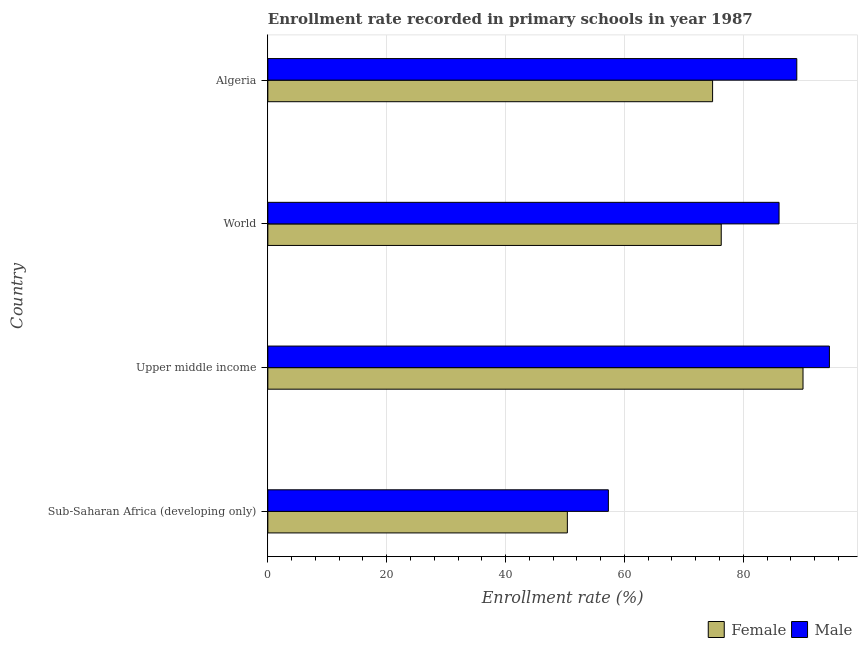How many groups of bars are there?
Keep it short and to the point. 4. Are the number of bars per tick equal to the number of legend labels?
Your response must be concise. Yes. Are the number of bars on each tick of the Y-axis equal?
Provide a succinct answer. Yes. How many bars are there on the 3rd tick from the top?
Give a very brief answer. 2. How many bars are there on the 4th tick from the bottom?
Your answer should be compact. 2. What is the label of the 3rd group of bars from the top?
Provide a short and direct response. Upper middle income. What is the enrollment rate of male students in World?
Your response must be concise. 86.02. Across all countries, what is the maximum enrollment rate of female students?
Offer a terse response. 90.05. Across all countries, what is the minimum enrollment rate of male students?
Give a very brief answer. 57.3. In which country was the enrollment rate of male students maximum?
Provide a succinct answer. Upper middle income. In which country was the enrollment rate of female students minimum?
Your answer should be compact. Sub-Saharan Africa (developing only). What is the total enrollment rate of male students in the graph?
Provide a short and direct response. 326.83. What is the difference between the enrollment rate of female students in Algeria and that in World?
Provide a succinct answer. -1.46. What is the difference between the enrollment rate of female students in World and the enrollment rate of male students in Upper middle income?
Give a very brief answer. -18.2. What is the average enrollment rate of male students per country?
Give a very brief answer. 81.71. What is the difference between the enrollment rate of male students and enrollment rate of female students in Sub-Saharan Africa (developing only)?
Provide a short and direct response. 6.9. In how many countries, is the enrollment rate of female students greater than 20 %?
Offer a terse response. 4. Is the difference between the enrollment rate of male students in Algeria and Upper middle income greater than the difference between the enrollment rate of female students in Algeria and Upper middle income?
Offer a very short reply. Yes. What is the difference between the highest and the second highest enrollment rate of female students?
Keep it short and to the point. 13.76. What is the difference between the highest and the lowest enrollment rate of male students?
Your response must be concise. 37.19. In how many countries, is the enrollment rate of male students greater than the average enrollment rate of male students taken over all countries?
Give a very brief answer. 3. What does the 2nd bar from the top in Upper middle income represents?
Keep it short and to the point. Female. What does the 2nd bar from the bottom in World represents?
Offer a very short reply. Male. How many bars are there?
Provide a succinct answer. 8. How many countries are there in the graph?
Offer a terse response. 4. What is the difference between two consecutive major ticks on the X-axis?
Your response must be concise. 20. Are the values on the major ticks of X-axis written in scientific E-notation?
Keep it short and to the point. No. Does the graph contain any zero values?
Offer a very short reply. No. How are the legend labels stacked?
Make the answer very short. Horizontal. What is the title of the graph?
Ensure brevity in your answer.  Enrollment rate recorded in primary schools in year 1987. What is the label or title of the X-axis?
Keep it short and to the point. Enrollment rate (%). What is the label or title of the Y-axis?
Provide a succinct answer. Country. What is the Enrollment rate (%) of Female in Sub-Saharan Africa (developing only)?
Offer a terse response. 50.4. What is the Enrollment rate (%) of Male in Sub-Saharan Africa (developing only)?
Make the answer very short. 57.3. What is the Enrollment rate (%) of Female in Upper middle income?
Your answer should be compact. 90.05. What is the Enrollment rate (%) in Male in Upper middle income?
Your answer should be very brief. 94.5. What is the Enrollment rate (%) in Female in World?
Ensure brevity in your answer.  76.29. What is the Enrollment rate (%) in Male in World?
Offer a terse response. 86.02. What is the Enrollment rate (%) of Female in Algeria?
Provide a short and direct response. 74.84. What is the Enrollment rate (%) in Male in Algeria?
Offer a terse response. 89.01. Across all countries, what is the maximum Enrollment rate (%) of Female?
Your response must be concise. 90.05. Across all countries, what is the maximum Enrollment rate (%) in Male?
Provide a succinct answer. 94.5. Across all countries, what is the minimum Enrollment rate (%) in Female?
Keep it short and to the point. 50.4. Across all countries, what is the minimum Enrollment rate (%) of Male?
Provide a succinct answer. 57.3. What is the total Enrollment rate (%) in Female in the graph?
Keep it short and to the point. 291.58. What is the total Enrollment rate (%) in Male in the graph?
Give a very brief answer. 326.83. What is the difference between the Enrollment rate (%) in Female in Sub-Saharan Africa (developing only) and that in Upper middle income?
Your answer should be compact. -39.65. What is the difference between the Enrollment rate (%) of Male in Sub-Saharan Africa (developing only) and that in Upper middle income?
Offer a terse response. -37.19. What is the difference between the Enrollment rate (%) of Female in Sub-Saharan Africa (developing only) and that in World?
Provide a succinct answer. -25.89. What is the difference between the Enrollment rate (%) in Male in Sub-Saharan Africa (developing only) and that in World?
Ensure brevity in your answer.  -28.72. What is the difference between the Enrollment rate (%) of Female in Sub-Saharan Africa (developing only) and that in Algeria?
Make the answer very short. -24.44. What is the difference between the Enrollment rate (%) in Male in Sub-Saharan Africa (developing only) and that in Algeria?
Offer a very short reply. -31.7. What is the difference between the Enrollment rate (%) in Female in Upper middle income and that in World?
Keep it short and to the point. 13.76. What is the difference between the Enrollment rate (%) of Male in Upper middle income and that in World?
Offer a terse response. 8.47. What is the difference between the Enrollment rate (%) in Female in Upper middle income and that in Algeria?
Your response must be concise. 15.22. What is the difference between the Enrollment rate (%) of Male in Upper middle income and that in Algeria?
Your answer should be very brief. 5.49. What is the difference between the Enrollment rate (%) of Female in World and that in Algeria?
Offer a very short reply. 1.46. What is the difference between the Enrollment rate (%) in Male in World and that in Algeria?
Provide a succinct answer. -2.98. What is the difference between the Enrollment rate (%) of Female in Sub-Saharan Africa (developing only) and the Enrollment rate (%) of Male in Upper middle income?
Keep it short and to the point. -44.1. What is the difference between the Enrollment rate (%) of Female in Sub-Saharan Africa (developing only) and the Enrollment rate (%) of Male in World?
Offer a very short reply. -35.62. What is the difference between the Enrollment rate (%) of Female in Sub-Saharan Africa (developing only) and the Enrollment rate (%) of Male in Algeria?
Make the answer very short. -38.61. What is the difference between the Enrollment rate (%) of Female in Upper middle income and the Enrollment rate (%) of Male in World?
Keep it short and to the point. 4.03. What is the difference between the Enrollment rate (%) in Female in Upper middle income and the Enrollment rate (%) in Male in Algeria?
Offer a terse response. 1.05. What is the difference between the Enrollment rate (%) in Female in World and the Enrollment rate (%) in Male in Algeria?
Provide a succinct answer. -12.71. What is the average Enrollment rate (%) of Female per country?
Your response must be concise. 72.9. What is the average Enrollment rate (%) in Male per country?
Provide a succinct answer. 81.71. What is the difference between the Enrollment rate (%) in Female and Enrollment rate (%) in Male in Sub-Saharan Africa (developing only)?
Your answer should be very brief. -6.9. What is the difference between the Enrollment rate (%) of Female and Enrollment rate (%) of Male in Upper middle income?
Your response must be concise. -4.44. What is the difference between the Enrollment rate (%) of Female and Enrollment rate (%) of Male in World?
Offer a terse response. -9.73. What is the difference between the Enrollment rate (%) in Female and Enrollment rate (%) in Male in Algeria?
Your response must be concise. -14.17. What is the ratio of the Enrollment rate (%) in Female in Sub-Saharan Africa (developing only) to that in Upper middle income?
Your answer should be very brief. 0.56. What is the ratio of the Enrollment rate (%) in Male in Sub-Saharan Africa (developing only) to that in Upper middle income?
Give a very brief answer. 0.61. What is the ratio of the Enrollment rate (%) of Female in Sub-Saharan Africa (developing only) to that in World?
Provide a short and direct response. 0.66. What is the ratio of the Enrollment rate (%) in Male in Sub-Saharan Africa (developing only) to that in World?
Offer a very short reply. 0.67. What is the ratio of the Enrollment rate (%) of Female in Sub-Saharan Africa (developing only) to that in Algeria?
Provide a succinct answer. 0.67. What is the ratio of the Enrollment rate (%) in Male in Sub-Saharan Africa (developing only) to that in Algeria?
Provide a short and direct response. 0.64. What is the ratio of the Enrollment rate (%) of Female in Upper middle income to that in World?
Your response must be concise. 1.18. What is the ratio of the Enrollment rate (%) in Male in Upper middle income to that in World?
Offer a very short reply. 1.1. What is the ratio of the Enrollment rate (%) in Female in Upper middle income to that in Algeria?
Give a very brief answer. 1.2. What is the ratio of the Enrollment rate (%) in Male in Upper middle income to that in Algeria?
Your answer should be very brief. 1.06. What is the ratio of the Enrollment rate (%) of Female in World to that in Algeria?
Ensure brevity in your answer.  1.02. What is the ratio of the Enrollment rate (%) of Male in World to that in Algeria?
Give a very brief answer. 0.97. What is the difference between the highest and the second highest Enrollment rate (%) of Female?
Your response must be concise. 13.76. What is the difference between the highest and the second highest Enrollment rate (%) of Male?
Provide a short and direct response. 5.49. What is the difference between the highest and the lowest Enrollment rate (%) in Female?
Your response must be concise. 39.65. What is the difference between the highest and the lowest Enrollment rate (%) in Male?
Make the answer very short. 37.19. 